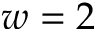<formula> <loc_0><loc_0><loc_500><loc_500>w = 2</formula> 